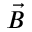Convert formula to latex. <formula><loc_0><loc_0><loc_500><loc_500>\vec { B }</formula> 